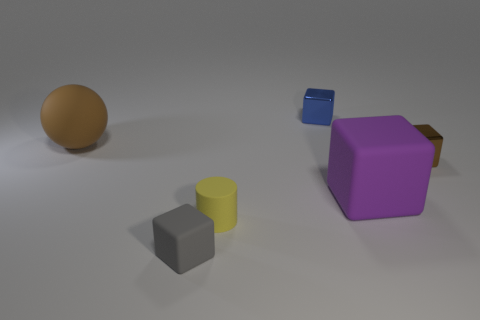Add 1 purple balls. How many objects exist? 7 Subtract all purple blocks. How many blocks are left? 3 Subtract all brown blocks. How many blocks are left? 3 Subtract all yellow cubes. Subtract all cyan spheres. How many cubes are left? 4 Subtract all blocks. How many objects are left? 2 Subtract 0 gray balls. How many objects are left? 6 Subtract all small metal blocks. Subtract all tiny yellow matte cylinders. How many objects are left? 3 Add 5 rubber balls. How many rubber balls are left? 6 Add 4 small blue metallic objects. How many small blue metallic objects exist? 5 